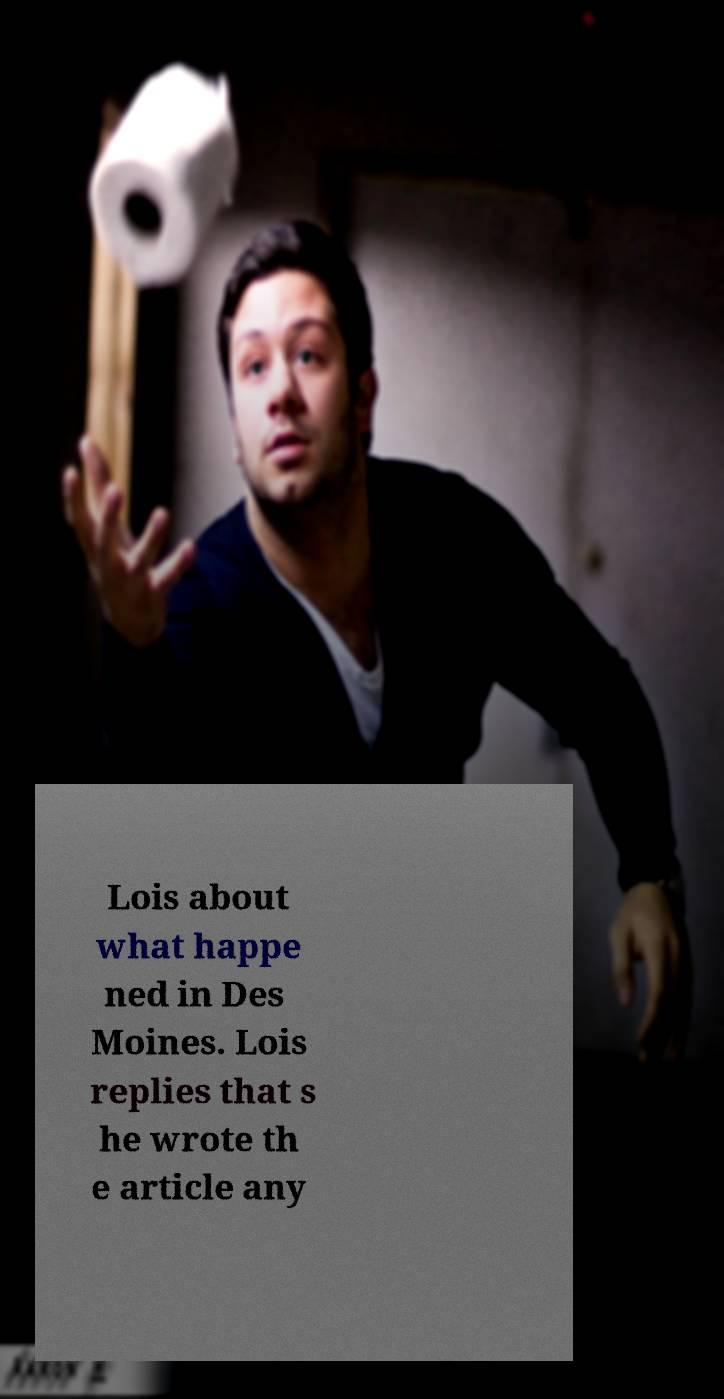I need the written content from this picture converted into text. Can you do that? Lois about what happe ned in Des Moines. Lois replies that s he wrote th e article any 